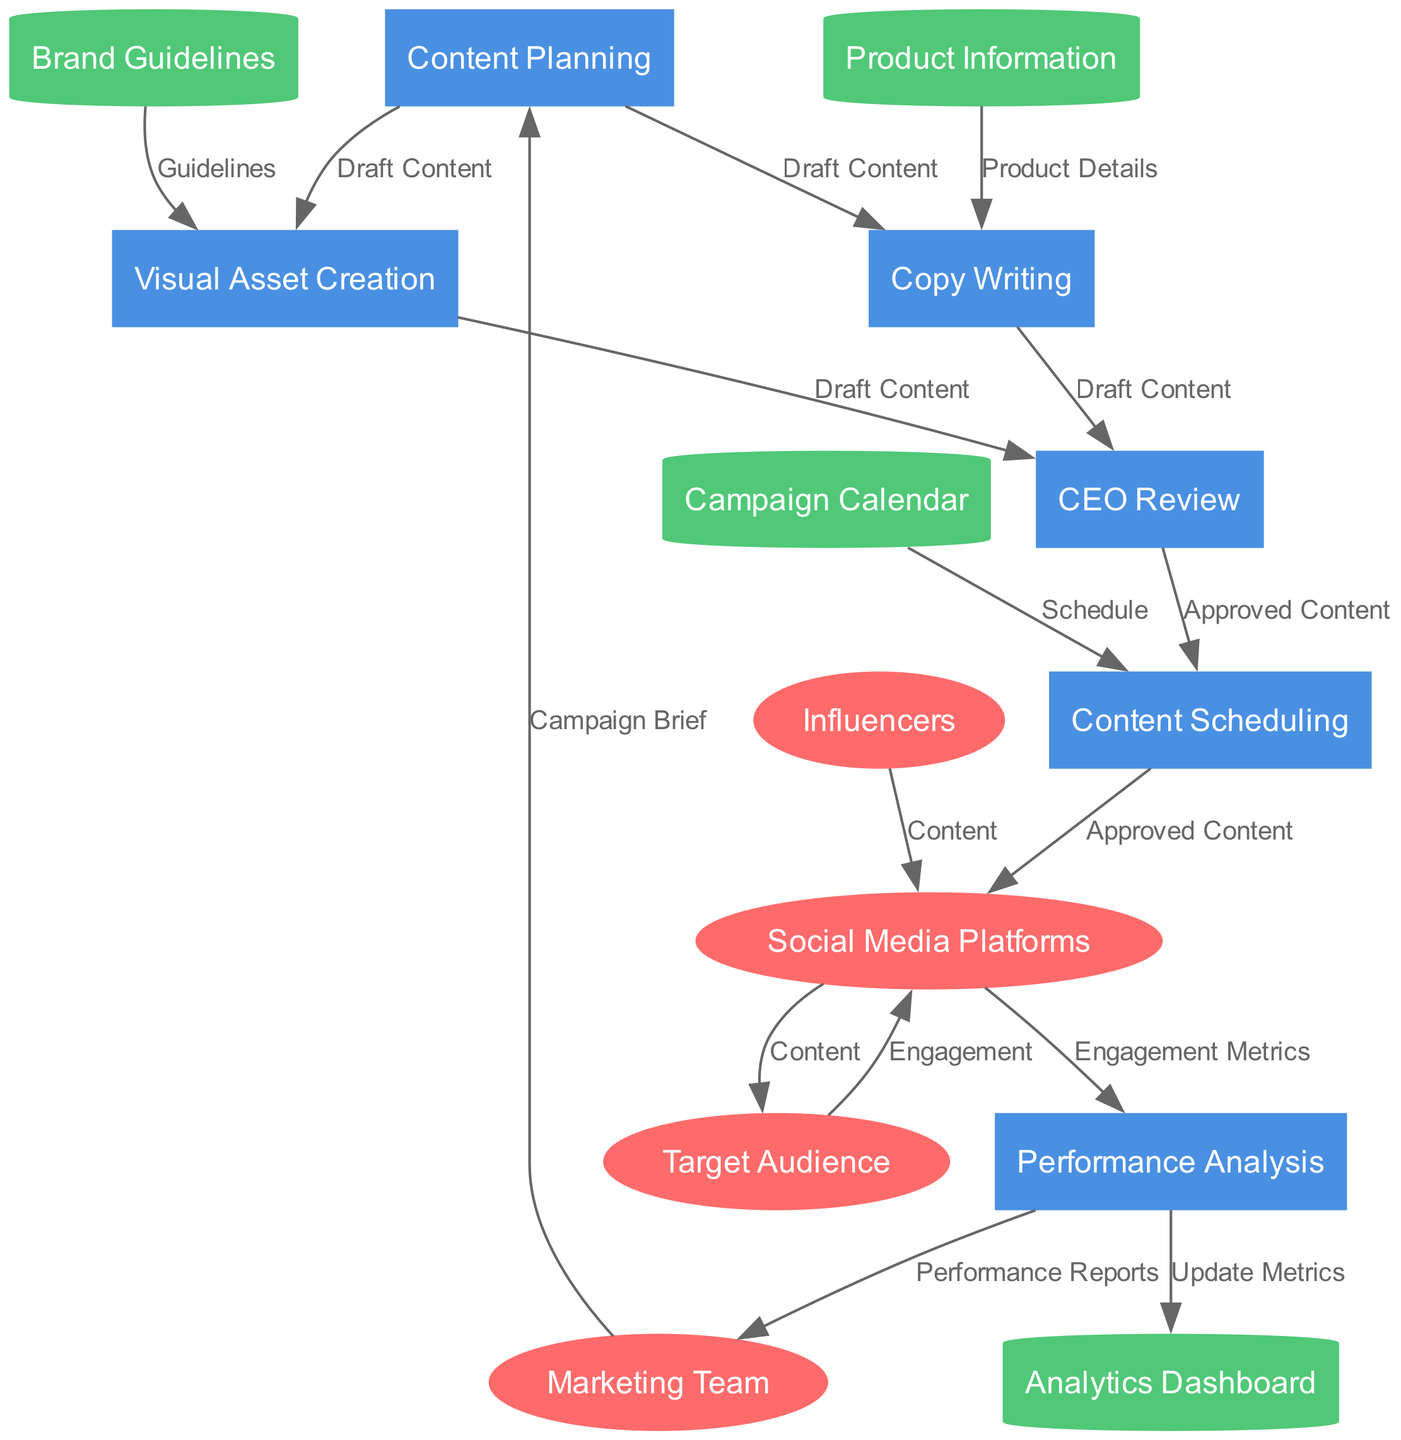What are the external entities in the diagram? The external entities are specifically listed in the diagram, including Social Media Platforms, Influencers, Target Audience, and Marketing Team. They are distinct entities that interact with the internal processes.
Answer: Social Media Platforms, Influencers, Target Audience, Marketing Team How many processes are depicted in the diagram? The diagram lists several processes, which can be counted individually. The processes include Content Planning, Visual Asset Creation, Copy Writing, CEO Review, Content Scheduling, and Performance Analysis, totaling six processes.
Answer: 6 What is the relationship between 'Content Planning' and 'Visual Asset Creation'? The diagram shows that 'Content Planning' flows into 'Visual Asset Creation' with the label 'Draft Content', indicating that Draft Content is the input required for Visual Asset Creation.
Answer: Draft Content Which data store is used by the 'Copy Writing' process? From the diagram, it is evident that 'Product Information' flows into the 'Copy Writing' process, meaning 'Copy Writing’ relies on details from this data store.
Answer: Product Information What kind of feedback does 'Social Media Platforms' send to 'Target Audience'? In the diagram, there’s a bi-directional flow between 'Social Media Platforms' and 'Target Audience', where 'Social Media Platforms' sends 'Content' to 'Target Audience', indicating what they receive.
Answer: Content What is the final output from 'Performance Analysis' to 'Marketing Team'? The diagram clearly depicts that the output from 'Performance Analysis' to 'Marketing Team' is delivered through ‘Performance Reports’, which summarizes the analytics from the campaign.
Answer: Performance Reports How does 'CEO Review' affect 'Content Scheduling'? The arrow connecting 'CEO Review' to 'Content Scheduling' labeled 'Approved Content' indicates that only content that has passed the CEO Review will move forward to be scheduled.
Answer: Approved Content Which process receives data from both 'Visual Asset Creation' and 'Copy Writing'? The 'CEO Review' process receives input concurrently from both 'Visual Asset Creation' and 'Copy Writing', as shown by the arrows pointing towards 'CEO Review' from these two processes.
Answer: CEO Review 